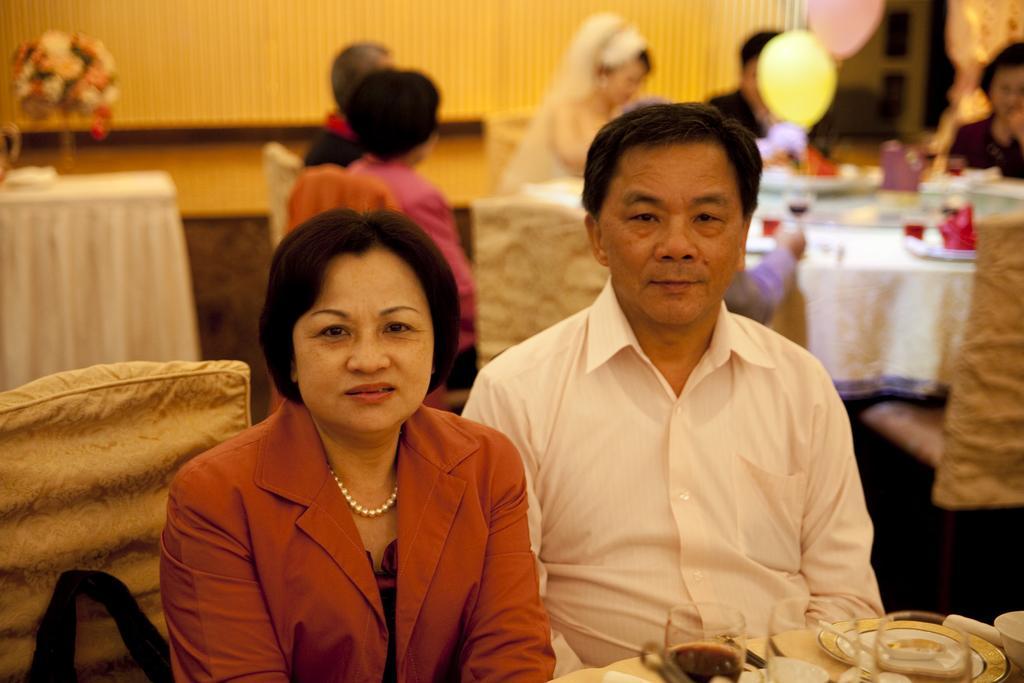How would you summarize this image in a sentence or two? Here I can see a man and a woman sitting and looking at the picture. In front of these people there is a table on which few glasses, plates and some other objects are placed. In the background there is another table which is covered with a cloth. On the table glasses, plates, papers and some other objects are placed. Around the table few people are sitting on the chairs. On the left side there is a flower vase on a table. In the background there is a wall and also I can see few balloons. 